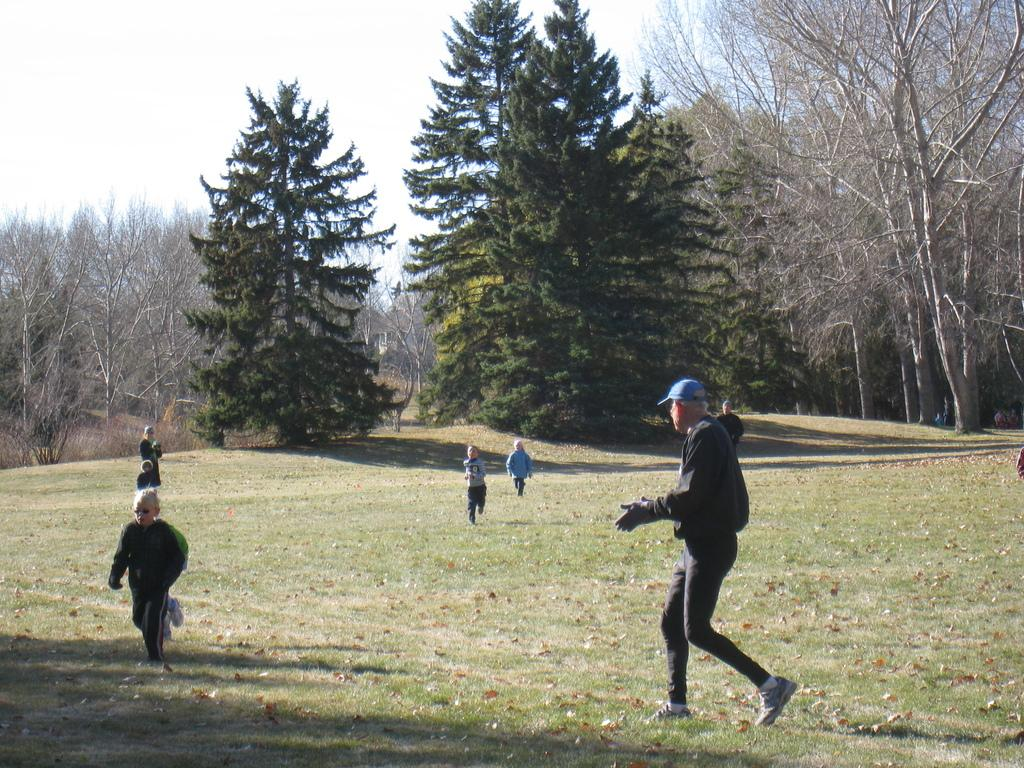What are the persons in the image doing? The persons in the image are running. What can be seen in the background of the image? There are trees in the background of the image. What type of terrain is visible in the image? There is grass on the ground in the image. What else can be found on the ground in the image? There are dry leaves on the ground in the image. How many oranges are hanging from the trees in the image? There are no oranges present in the image; it features persons running and trees in the background. What type of pin can be seen holding the hill together in the image? There is no hill or pin present in the image. 